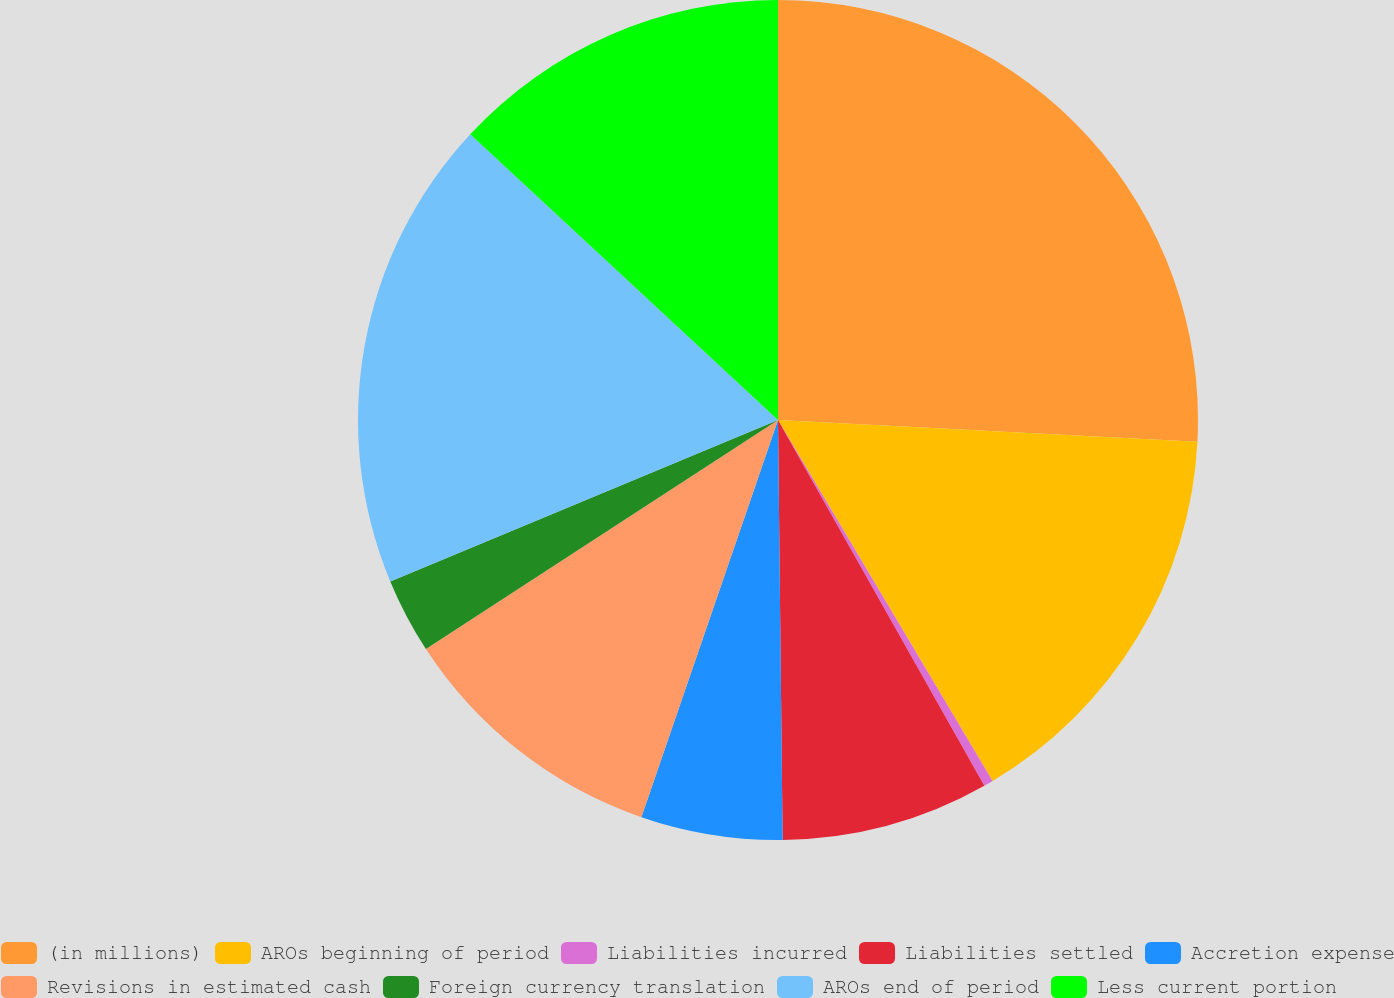Convert chart to OTSL. <chart><loc_0><loc_0><loc_500><loc_500><pie_chart><fcel>(in millions)<fcel>AROs beginning of period<fcel>Liabilities incurred<fcel>Liabilities settled<fcel>Accretion expense<fcel>Revisions in estimated cash<fcel>Foreign currency translation<fcel>AROs end of period<fcel>Less current portion<nl><fcel>25.83%<fcel>15.64%<fcel>0.36%<fcel>8.0%<fcel>5.45%<fcel>10.55%<fcel>2.9%<fcel>18.19%<fcel>13.09%<nl></chart> 